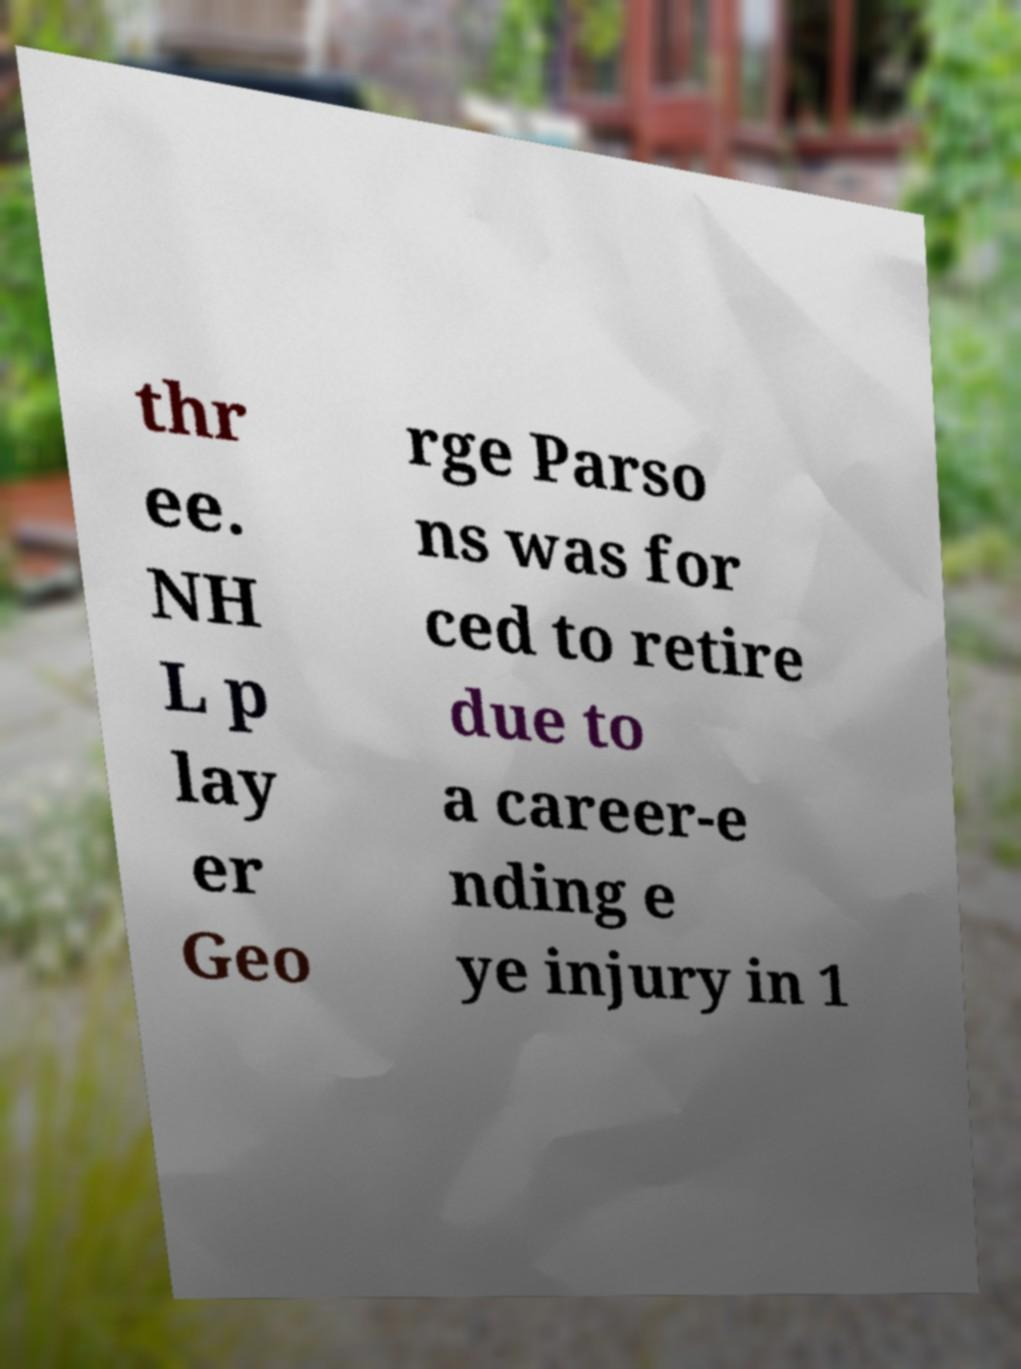For documentation purposes, I need the text within this image transcribed. Could you provide that? thr ee. NH L p lay er Geo rge Parso ns was for ced to retire due to a career-e nding e ye injury in 1 